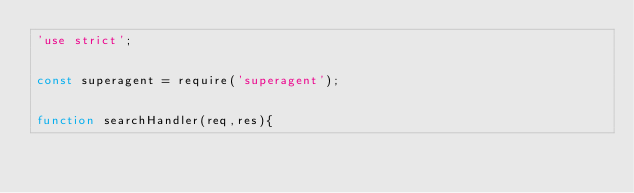<code> <loc_0><loc_0><loc_500><loc_500><_JavaScript_>'use strict';


const superagent = require('superagent');


function searchHandler(req,res){</code> 